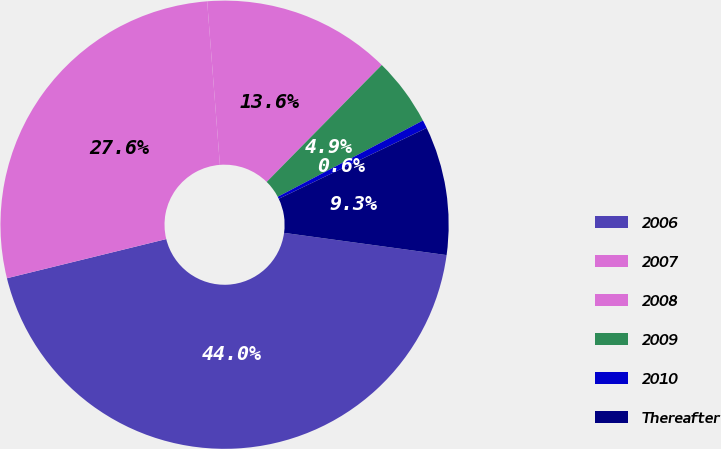<chart> <loc_0><loc_0><loc_500><loc_500><pie_chart><fcel>2006<fcel>2007<fcel>2008<fcel>2009<fcel>2010<fcel>Thereafter<nl><fcel>44.0%<fcel>27.6%<fcel>13.61%<fcel>4.93%<fcel>0.59%<fcel>9.27%<nl></chart> 